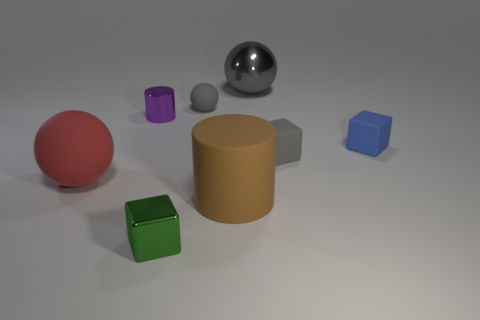Add 2 purple cylinders. How many objects exist? 10 Subtract all balls. How many objects are left? 5 Subtract all big rubber things. Subtract all large gray shiny spheres. How many objects are left? 5 Add 5 tiny gray matte blocks. How many tiny gray matte blocks are left? 6 Add 2 brown objects. How many brown objects exist? 3 Subtract 1 brown cylinders. How many objects are left? 7 